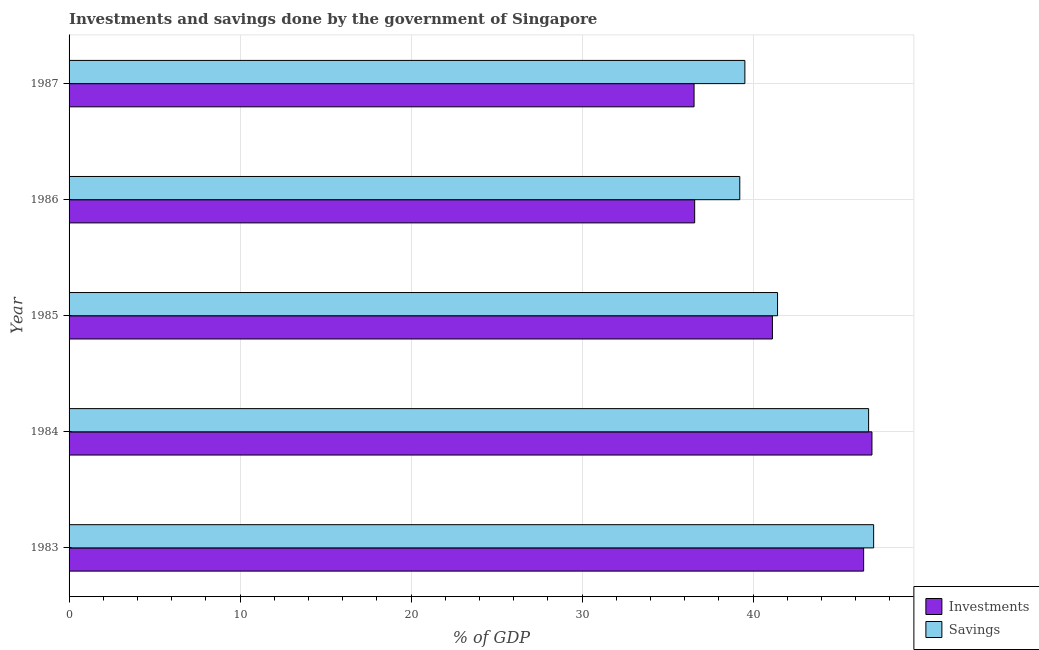Are the number of bars per tick equal to the number of legend labels?
Ensure brevity in your answer.  Yes. How many bars are there on the 1st tick from the bottom?
Your response must be concise. 2. What is the savings of government in 1984?
Offer a terse response. 46.76. Across all years, what is the maximum savings of government?
Give a very brief answer. 47.05. Across all years, what is the minimum savings of government?
Your response must be concise. 39.23. What is the total investments of government in the graph?
Keep it short and to the point. 207.7. What is the difference between the investments of government in 1984 and that in 1987?
Make the answer very short. 10.4. What is the difference between the investments of government in 1986 and the savings of government in 1983?
Offer a very short reply. -10.47. What is the average investments of government per year?
Your response must be concise. 41.54. In the year 1983, what is the difference between the investments of government and savings of government?
Your answer should be very brief. -0.58. In how many years, is the savings of government greater than 6 %?
Ensure brevity in your answer.  5. What is the ratio of the investments of government in 1986 to that in 1987?
Make the answer very short. 1. What is the difference between the highest and the second highest investments of government?
Offer a very short reply. 0.49. What does the 1st bar from the top in 1987 represents?
Offer a terse response. Savings. What does the 2nd bar from the bottom in 1984 represents?
Offer a terse response. Savings. How many bars are there?
Your answer should be very brief. 10. Does the graph contain grids?
Give a very brief answer. Yes. Where does the legend appear in the graph?
Make the answer very short. Bottom right. How many legend labels are there?
Ensure brevity in your answer.  2. What is the title of the graph?
Keep it short and to the point. Investments and savings done by the government of Singapore. Does "Total Population" appear as one of the legend labels in the graph?
Offer a very short reply. No. What is the label or title of the X-axis?
Provide a succinct answer. % of GDP. What is the % of GDP of Investments in 1983?
Provide a succinct answer. 46.47. What is the % of GDP of Savings in 1983?
Give a very brief answer. 47.05. What is the % of GDP in Investments in 1984?
Provide a short and direct response. 46.95. What is the % of GDP of Savings in 1984?
Your answer should be compact. 46.76. What is the % of GDP of Investments in 1985?
Your response must be concise. 41.13. What is the % of GDP in Savings in 1985?
Provide a short and direct response. 41.43. What is the % of GDP of Investments in 1986?
Ensure brevity in your answer.  36.59. What is the % of GDP in Savings in 1986?
Offer a very short reply. 39.23. What is the % of GDP in Investments in 1987?
Your answer should be compact. 36.55. What is the % of GDP in Savings in 1987?
Keep it short and to the point. 39.52. Across all years, what is the maximum % of GDP in Investments?
Give a very brief answer. 46.95. Across all years, what is the maximum % of GDP in Savings?
Your answer should be very brief. 47.05. Across all years, what is the minimum % of GDP of Investments?
Your answer should be very brief. 36.55. Across all years, what is the minimum % of GDP of Savings?
Offer a terse response. 39.23. What is the total % of GDP in Investments in the graph?
Ensure brevity in your answer.  207.7. What is the total % of GDP of Savings in the graph?
Offer a very short reply. 213.99. What is the difference between the % of GDP of Investments in 1983 and that in 1984?
Your response must be concise. -0.49. What is the difference between the % of GDP of Savings in 1983 and that in 1984?
Give a very brief answer. 0.29. What is the difference between the % of GDP of Investments in 1983 and that in 1985?
Your response must be concise. 5.34. What is the difference between the % of GDP of Savings in 1983 and that in 1985?
Your answer should be compact. 5.62. What is the difference between the % of GDP in Investments in 1983 and that in 1986?
Offer a very short reply. 9.88. What is the difference between the % of GDP in Savings in 1983 and that in 1986?
Provide a short and direct response. 7.83. What is the difference between the % of GDP in Investments in 1983 and that in 1987?
Offer a very short reply. 9.92. What is the difference between the % of GDP of Savings in 1983 and that in 1987?
Your response must be concise. 7.53. What is the difference between the % of GDP in Investments in 1984 and that in 1985?
Keep it short and to the point. 5.82. What is the difference between the % of GDP of Savings in 1984 and that in 1985?
Make the answer very short. 5.33. What is the difference between the % of GDP in Investments in 1984 and that in 1986?
Your answer should be compact. 10.37. What is the difference between the % of GDP in Savings in 1984 and that in 1986?
Keep it short and to the point. 7.53. What is the difference between the % of GDP of Investments in 1984 and that in 1987?
Your answer should be compact. 10.4. What is the difference between the % of GDP in Savings in 1984 and that in 1987?
Ensure brevity in your answer.  7.24. What is the difference between the % of GDP in Investments in 1985 and that in 1986?
Make the answer very short. 4.55. What is the difference between the % of GDP of Savings in 1985 and that in 1986?
Make the answer very short. 2.21. What is the difference between the % of GDP of Investments in 1985 and that in 1987?
Provide a short and direct response. 4.58. What is the difference between the % of GDP of Savings in 1985 and that in 1987?
Your response must be concise. 1.91. What is the difference between the % of GDP of Investments in 1986 and that in 1987?
Provide a short and direct response. 0.04. What is the difference between the % of GDP in Savings in 1986 and that in 1987?
Your answer should be very brief. -0.3. What is the difference between the % of GDP of Investments in 1983 and the % of GDP of Savings in 1984?
Make the answer very short. -0.29. What is the difference between the % of GDP in Investments in 1983 and the % of GDP in Savings in 1985?
Offer a very short reply. 5.04. What is the difference between the % of GDP in Investments in 1983 and the % of GDP in Savings in 1986?
Your answer should be very brief. 7.24. What is the difference between the % of GDP of Investments in 1983 and the % of GDP of Savings in 1987?
Offer a very short reply. 6.95. What is the difference between the % of GDP of Investments in 1984 and the % of GDP of Savings in 1985?
Your answer should be very brief. 5.52. What is the difference between the % of GDP of Investments in 1984 and the % of GDP of Savings in 1986?
Ensure brevity in your answer.  7.73. What is the difference between the % of GDP of Investments in 1984 and the % of GDP of Savings in 1987?
Offer a very short reply. 7.43. What is the difference between the % of GDP in Investments in 1985 and the % of GDP in Savings in 1986?
Provide a succinct answer. 1.91. What is the difference between the % of GDP of Investments in 1985 and the % of GDP of Savings in 1987?
Make the answer very short. 1.61. What is the difference between the % of GDP of Investments in 1986 and the % of GDP of Savings in 1987?
Your response must be concise. -2.94. What is the average % of GDP in Investments per year?
Your answer should be compact. 41.54. What is the average % of GDP in Savings per year?
Your answer should be compact. 42.8. In the year 1983, what is the difference between the % of GDP of Investments and % of GDP of Savings?
Your response must be concise. -0.58. In the year 1984, what is the difference between the % of GDP of Investments and % of GDP of Savings?
Offer a terse response. 0.2. In the year 1985, what is the difference between the % of GDP of Investments and % of GDP of Savings?
Your answer should be compact. -0.3. In the year 1986, what is the difference between the % of GDP of Investments and % of GDP of Savings?
Keep it short and to the point. -2.64. In the year 1987, what is the difference between the % of GDP in Investments and % of GDP in Savings?
Give a very brief answer. -2.97. What is the ratio of the % of GDP of Savings in 1983 to that in 1984?
Give a very brief answer. 1.01. What is the ratio of the % of GDP of Investments in 1983 to that in 1985?
Provide a short and direct response. 1.13. What is the ratio of the % of GDP in Savings in 1983 to that in 1985?
Provide a succinct answer. 1.14. What is the ratio of the % of GDP in Investments in 1983 to that in 1986?
Offer a terse response. 1.27. What is the ratio of the % of GDP of Savings in 1983 to that in 1986?
Offer a terse response. 1.2. What is the ratio of the % of GDP in Investments in 1983 to that in 1987?
Make the answer very short. 1.27. What is the ratio of the % of GDP of Savings in 1983 to that in 1987?
Your answer should be compact. 1.19. What is the ratio of the % of GDP in Investments in 1984 to that in 1985?
Make the answer very short. 1.14. What is the ratio of the % of GDP of Savings in 1984 to that in 1985?
Your response must be concise. 1.13. What is the ratio of the % of GDP in Investments in 1984 to that in 1986?
Your response must be concise. 1.28. What is the ratio of the % of GDP of Savings in 1984 to that in 1986?
Offer a terse response. 1.19. What is the ratio of the % of GDP of Investments in 1984 to that in 1987?
Keep it short and to the point. 1.28. What is the ratio of the % of GDP in Savings in 1984 to that in 1987?
Your answer should be compact. 1.18. What is the ratio of the % of GDP in Investments in 1985 to that in 1986?
Your answer should be very brief. 1.12. What is the ratio of the % of GDP of Savings in 1985 to that in 1986?
Make the answer very short. 1.06. What is the ratio of the % of GDP in Investments in 1985 to that in 1987?
Offer a terse response. 1.13. What is the ratio of the % of GDP of Savings in 1985 to that in 1987?
Keep it short and to the point. 1.05. What is the ratio of the % of GDP in Investments in 1986 to that in 1987?
Your response must be concise. 1. What is the ratio of the % of GDP of Savings in 1986 to that in 1987?
Offer a very short reply. 0.99. What is the difference between the highest and the second highest % of GDP of Investments?
Ensure brevity in your answer.  0.49. What is the difference between the highest and the second highest % of GDP of Savings?
Make the answer very short. 0.29. What is the difference between the highest and the lowest % of GDP of Investments?
Provide a short and direct response. 10.4. What is the difference between the highest and the lowest % of GDP of Savings?
Ensure brevity in your answer.  7.83. 